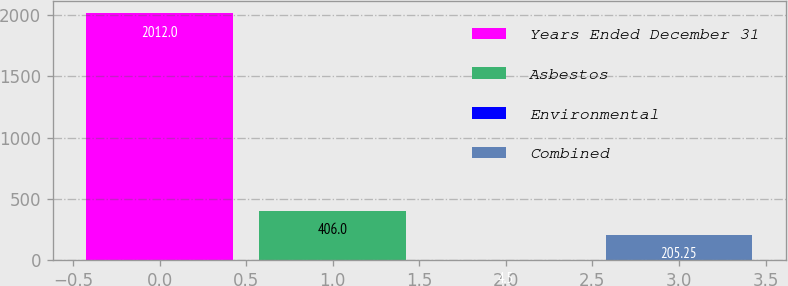<chart> <loc_0><loc_0><loc_500><loc_500><bar_chart><fcel>Years Ended December 31<fcel>Asbestos<fcel>Environmental<fcel>Combined<nl><fcel>2012<fcel>406<fcel>4.5<fcel>205.25<nl></chart> 